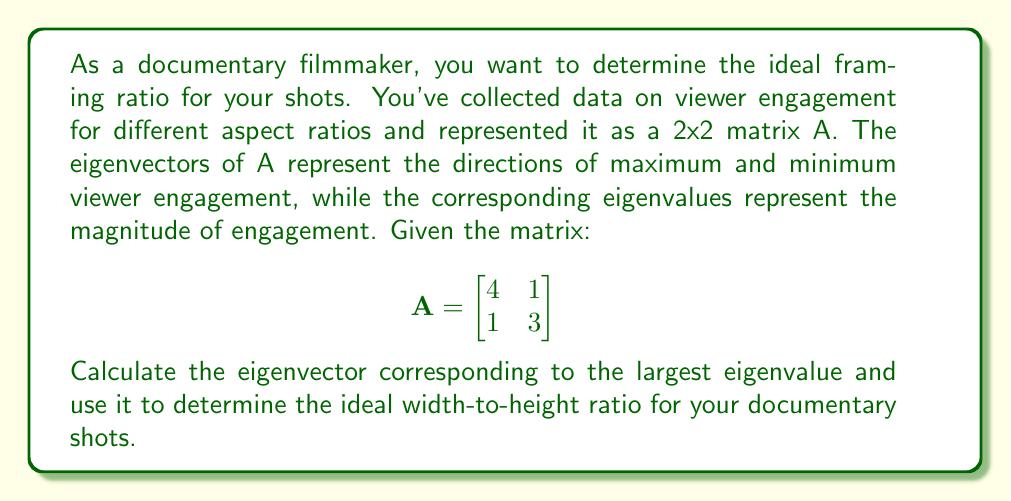Can you answer this question? 1) First, we need to find the eigenvalues of matrix A. The characteristic equation is:

   $$det(A - \lambda I) = \begin{vmatrix}
   4-\lambda & 1 \\
   1 & 3-\lambda
   \end{vmatrix} = (4-\lambda)(3-\lambda) - 1 = \lambda^2 - 7\lambda + 11 = 0$$

2) Solving this quadratic equation:
   $\lambda = \frac{7 \pm \sqrt{49 - 44}}{2} = \frac{7 \pm \sqrt{5}}{2}$

3) The larger eigenvalue is $\lambda_1 = \frac{7 + \sqrt{5}}{2}$

4) To find the corresponding eigenvector, we solve $(A - \lambda_1 I)v = 0$:

   $$\begin{bmatrix}
   4-\frac{7+\sqrt{5}}{2} & 1 \\
   1 & 3-\frac{7+\sqrt{5}}{2}
   \end{bmatrix} \begin{bmatrix} v_1 \\ v_2 \end{bmatrix} = \begin{bmatrix} 0 \\ 0 \end{bmatrix}$$

5) This simplifies to:
   $$\begin{bmatrix}
   \frac{1-\sqrt{5}}{2} & 1 \\
   1 & \frac{-1-\sqrt{5}}{2}
   \end{bmatrix} \begin{bmatrix} v_1 \\ v_2 \end{bmatrix} = \begin{bmatrix} 0 \\ 0 \end{bmatrix}$$

6) From the first row: $\frac{1-\sqrt{5}}{2}v_1 + v_2 = 0$
   
   $v_2 = \frac{\sqrt{5}-1}{2}v_1$

7) We can choose $v_1 = 2$ to simplify. Then $v_2 = \sqrt{5}-1$

8) The eigenvector is thus $v = \begin{bmatrix} 2 \\ \sqrt{5}-1 \end{bmatrix}$

9) The ideal width-to-height ratio is given by the components of this eigenvector:
   $\frac{width}{height} = \frac{2}{\sqrt{5}-1} \approx 1.618$
Answer: $1.618:1$ (or approximately $16:10$) 